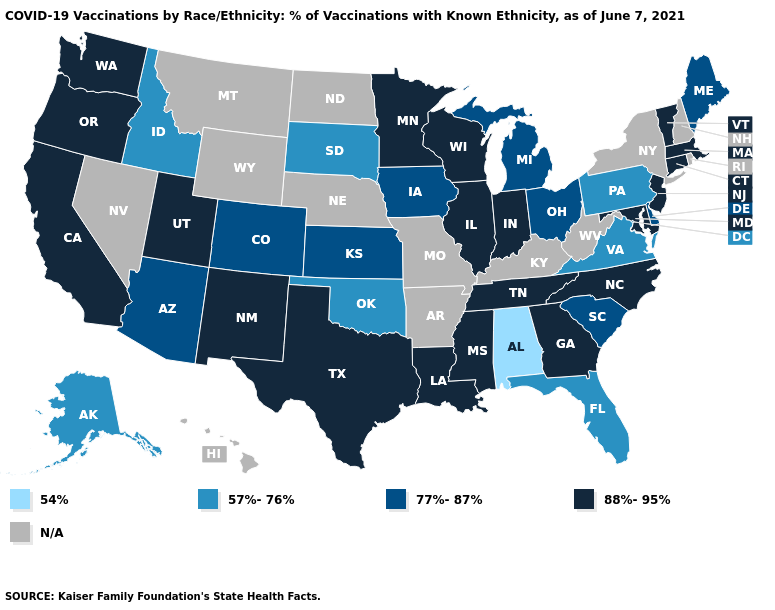Does Virginia have the highest value in the USA?
Quick response, please. No. Which states have the lowest value in the MidWest?
Keep it brief. South Dakota. Name the states that have a value in the range 77%-87%?
Answer briefly. Arizona, Colorado, Delaware, Iowa, Kansas, Maine, Michigan, Ohio, South Carolina. What is the highest value in the MidWest ?
Be succinct. 88%-95%. Which states hav the highest value in the South?
Write a very short answer. Georgia, Louisiana, Maryland, Mississippi, North Carolina, Tennessee, Texas. What is the value of Utah?
Write a very short answer. 88%-95%. Name the states that have a value in the range 57%-76%?
Give a very brief answer. Alaska, Florida, Idaho, Oklahoma, Pennsylvania, South Dakota, Virginia. What is the value of Louisiana?
Quick response, please. 88%-95%. Does New Mexico have the lowest value in the West?
Quick response, please. No. Does Louisiana have the lowest value in the USA?
Give a very brief answer. No. What is the highest value in the MidWest ?
Give a very brief answer. 88%-95%. Among the states that border Kansas , which have the lowest value?
Answer briefly. Oklahoma. Which states have the highest value in the USA?
Keep it brief. California, Connecticut, Georgia, Illinois, Indiana, Louisiana, Maryland, Massachusetts, Minnesota, Mississippi, New Jersey, New Mexico, North Carolina, Oregon, Tennessee, Texas, Utah, Vermont, Washington, Wisconsin. 